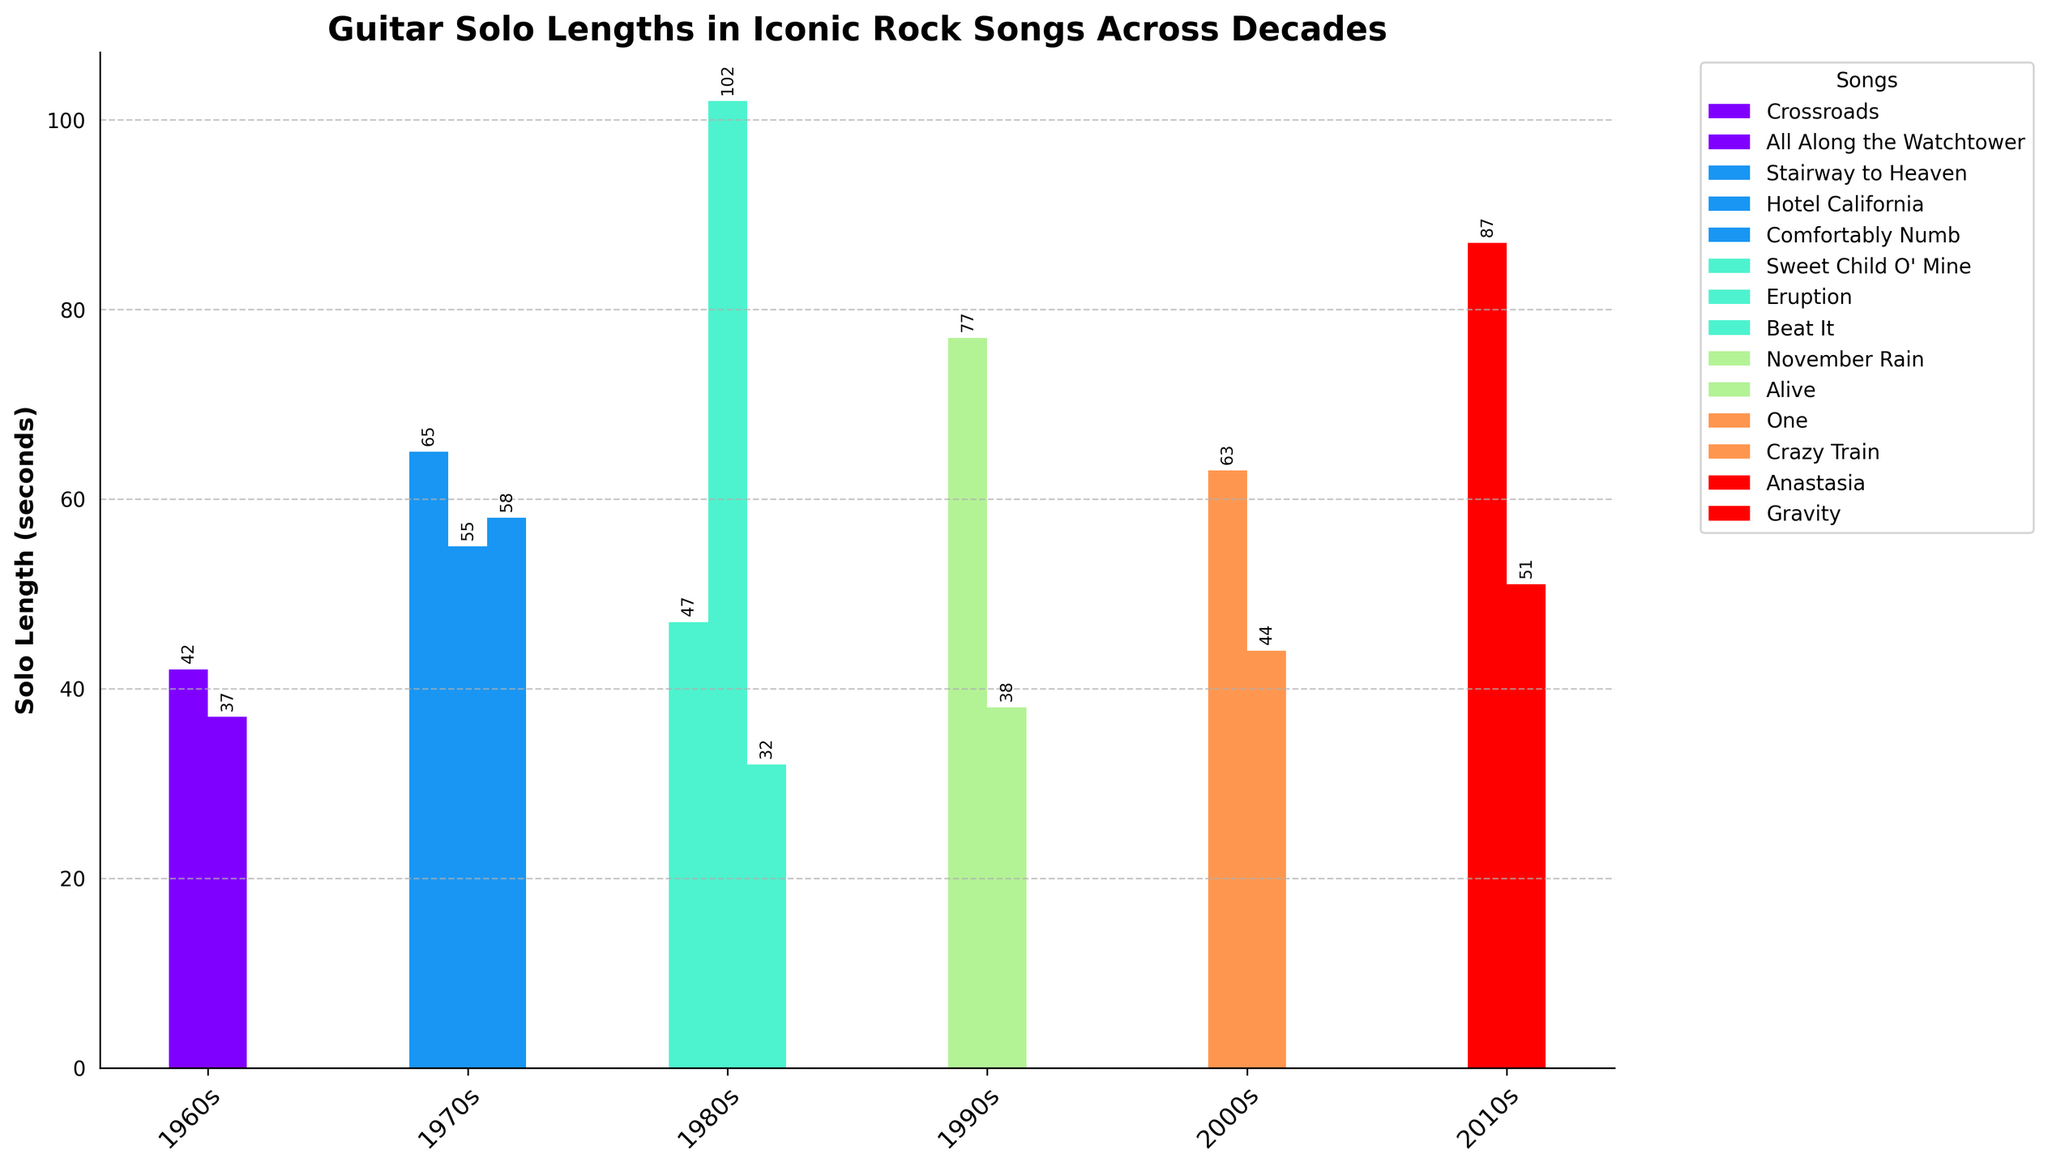Which song has the longest guitar solo? The bar representing "Eruption" by Van Halen is the tallest amongst all, indicating that it has the longest guitar solo.
Answer: Eruption Which decade has the shortest average solo length? The 1980s decade has a few short solos like "Beat It" (32 seconds) compared to other songs in the same decade. Average the lengths of solos in each decade to find the shortest, which is the 1980s.
Answer: 1980s What is the cumulative solo length for songs from the 1970s? Sum the heights of the bars for the 1970s: 65 (Stairway to Heaven) + 55 (Hotel California) + 58 (Comfortably Numb) = 178 seconds.
Answer: 178 seconds Which song from the 2010s has a longer solo, "Anastasia" or "Gravity"? Compare the heights of the bars: "Anastasia" by Slash (87 seconds) is taller than "Gravity" by John Mayer (51 seconds).
Answer: Anastasia How much longer is "November Rain" compared to "All Along the Watchtower"? "November Rain" is 77 seconds long, and "All Along the Watchtower" is 37 seconds. The difference is 77 - 37 = 40 seconds.
Answer: 40 seconds What is the overall trend in solo lengths across decades? Inspect the chart from left to right for changes in heights over decades. The trend shows fluctuation, with significant solos in the 70s, a peak in the 80s, and variations in subsequent decades.
Answer: Fluctuating Which two songs have the most similar solo lengths? Visually examining bar heights, "All Along the Watchtower" (37 seconds) and "Alive" (38 seconds) seem close in length.
Answer: All Along the Watchtower, Alive What is the difference between the total solo lengths of the 1990s and the 2000s? Sum the solo lengths for each decade and subtract: 1990s (77 + 38 = 115 seconds), 2000s (63 + 44 = 107 seconds). The difference is 115 - 107 = 8 seconds.
Answer: 8 seconds Which decade features the song with the highest solo length? The tallest single bar in the chart represents "Eruption" from the 1980s, hence the highest is in the 1980s.
Answer: 1980s Which colors represent the songs from the 1960s? Based on the visual information, identify the bars for the 1960s and their respective colors. This would involve noting the colors of the bars for "Crossroads" and "All Along the Watchtower".
Answer: (Provide specific colors based on the rendered figure) 